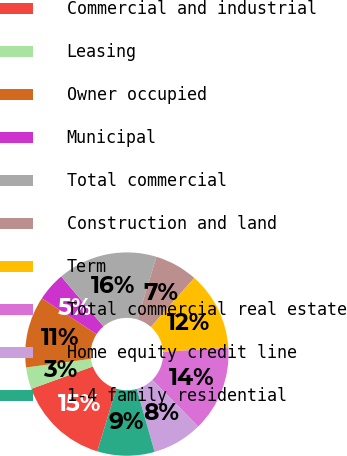Convert chart to OTSL. <chart><loc_0><loc_0><loc_500><loc_500><pie_chart><fcel>Commercial and industrial<fcel>Leasing<fcel>Owner occupied<fcel>Municipal<fcel>Total commercial<fcel>Construction and land<fcel>Term<fcel>Total commercial real estate<fcel>Home equity credit line<fcel>1-4 family residential<nl><fcel>14.74%<fcel>3.45%<fcel>11.35%<fcel>4.58%<fcel>15.87%<fcel>6.84%<fcel>12.48%<fcel>13.61%<fcel>7.97%<fcel>9.1%<nl></chart> 